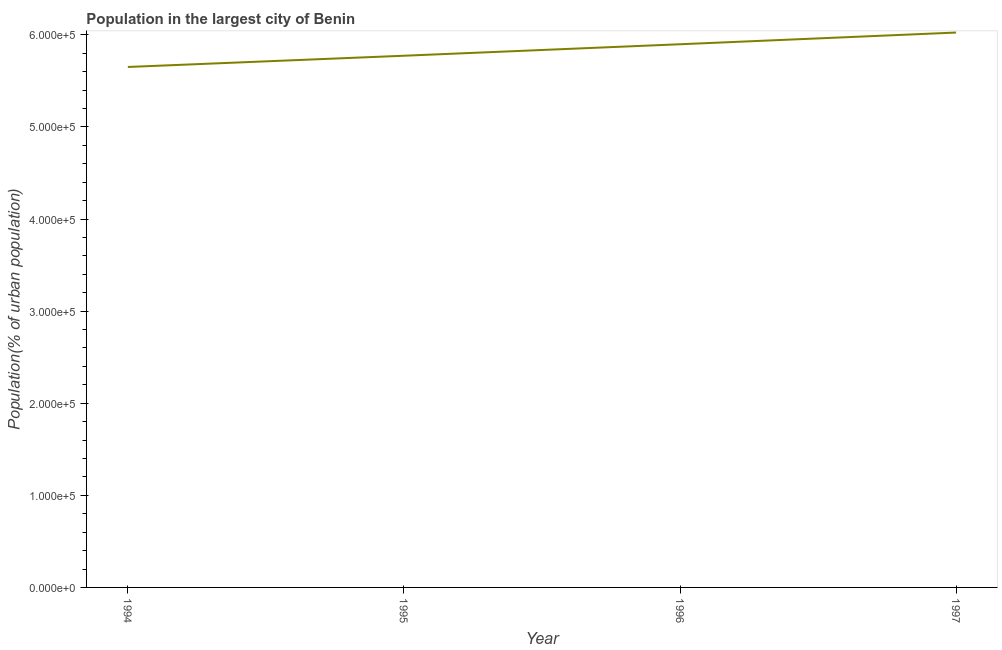What is the population in largest city in 1994?
Offer a very short reply. 5.65e+05. Across all years, what is the maximum population in largest city?
Ensure brevity in your answer.  6.03e+05. Across all years, what is the minimum population in largest city?
Your answer should be very brief. 5.65e+05. In which year was the population in largest city minimum?
Make the answer very short. 1994. What is the sum of the population in largest city?
Keep it short and to the point. 2.33e+06. What is the difference between the population in largest city in 1994 and 1995?
Your answer should be compact. -1.22e+04. What is the average population in largest city per year?
Your response must be concise. 5.84e+05. What is the median population in largest city?
Ensure brevity in your answer.  5.84e+05. What is the ratio of the population in largest city in 1994 to that in 1995?
Ensure brevity in your answer.  0.98. Is the population in largest city in 1994 less than that in 1995?
Keep it short and to the point. Yes. Is the difference between the population in largest city in 1996 and 1997 greater than the difference between any two years?
Offer a very short reply. No. What is the difference between the highest and the second highest population in largest city?
Provide a short and direct response. 1.27e+04. What is the difference between the highest and the lowest population in largest city?
Your answer should be compact. 3.74e+04. In how many years, is the population in largest city greater than the average population in largest city taken over all years?
Your answer should be very brief. 2. How many lines are there?
Keep it short and to the point. 1. Are the values on the major ticks of Y-axis written in scientific E-notation?
Your answer should be compact. Yes. Does the graph contain any zero values?
Make the answer very short. No. What is the title of the graph?
Keep it short and to the point. Population in the largest city of Benin. What is the label or title of the Y-axis?
Offer a very short reply. Population(% of urban population). What is the Population(% of urban population) in 1994?
Your answer should be compact. 5.65e+05. What is the Population(% of urban population) in 1995?
Provide a short and direct response. 5.77e+05. What is the Population(% of urban population) in 1996?
Make the answer very short. 5.90e+05. What is the Population(% of urban population) of 1997?
Offer a very short reply. 6.03e+05. What is the difference between the Population(% of urban population) in 1994 and 1995?
Offer a very short reply. -1.22e+04. What is the difference between the Population(% of urban population) in 1994 and 1996?
Make the answer very short. -2.47e+04. What is the difference between the Population(% of urban population) in 1994 and 1997?
Provide a short and direct response. -3.74e+04. What is the difference between the Population(% of urban population) in 1995 and 1996?
Ensure brevity in your answer.  -1.25e+04. What is the difference between the Population(% of urban population) in 1995 and 1997?
Keep it short and to the point. -2.52e+04. What is the difference between the Population(% of urban population) in 1996 and 1997?
Offer a terse response. -1.27e+04. What is the ratio of the Population(% of urban population) in 1994 to that in 1996?
Give a very brief answer. 0.96. What is the ratio of the Population(% of urban population) in 1994 to that in 1997?
Keep it short and to the point. 0.94. What is the ratio of the Population(% of urban population) in 1995 to that in 1996?
Your response must be concise. 0.98. What is the ratio of the Population(% of urban population) in 1995 to that in 1997?
Make the answer very short. 0.96. What is the ratio of the Population(% of urban population) in 1996 to that in 1997?
Offer a very short reply. 0.98. 